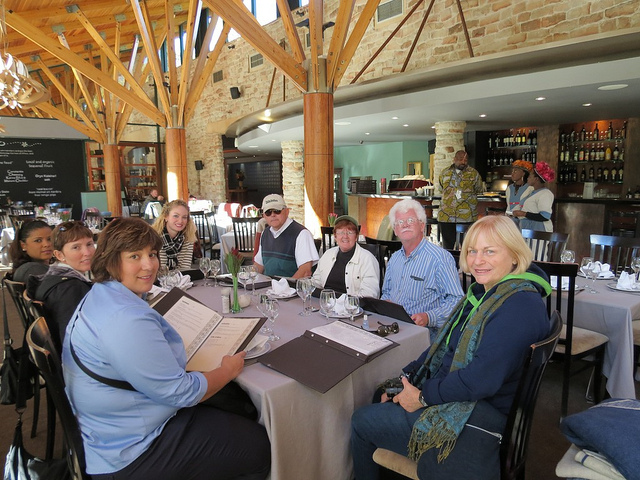<image>What vehicle is this taken in? There is no vehicle in the image. What vehicle is this taken in? I am not sure what vehicle this image was taken in. There doesn't appear to be any vehicle in the image. 